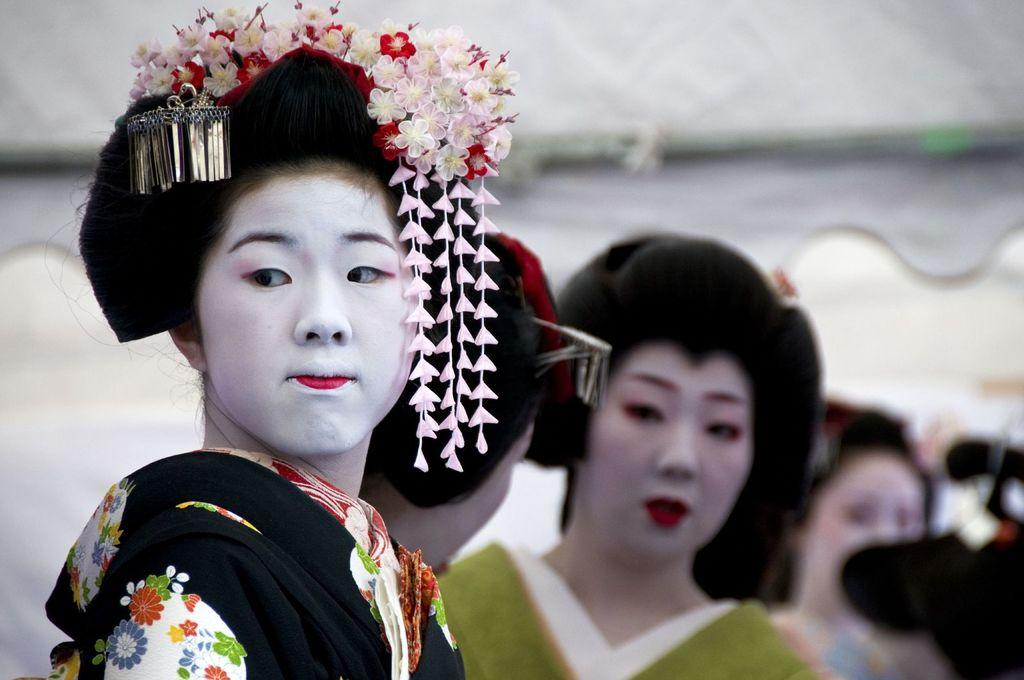How many people are present in the image? There are many people in the image. Can you describe the appearance of the lady in the front? The lady in the front has flowers on her head. What can be observed about the background of the image? The background appears blurry. What type of eggnog is being served on the side in the image? There is no eggnog present in the image. Is there a tramp performing in the background of the image? There is no tramp or any performance taking place in the image. 